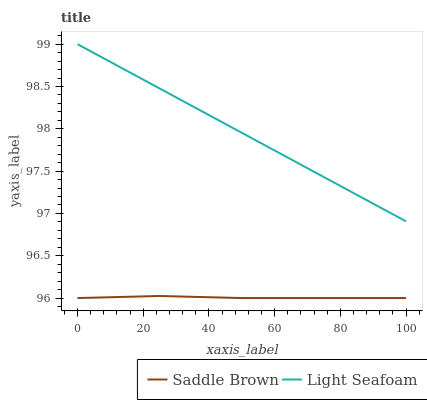Does Saddle Brown have the minimum area under the curve?
Answer yes or no. Yes. Does Light Seafoam have the maximum area under the curve?
Answer yes or no. Yes. Does Saddle Brown have the maximum area under the curve?
Answer yes or no. No. Is Light Seafoam the smoothest?
Answer yes or no. Yes. Is Saddle Brown the roughest?
Answer yes or no. Yes. Is Saddle Brown the smoothest?
Answer yes or no. No. Does Light Seafoam have the highest value?
Answer yes or no. Yes. Does Saddle Brown have the highest value?
Answer yes or no. No. Is Saddle Brown less than Light Seafoam?
Answer yes or no. Yes. Is Light Seafoam greater than Saddle Brown?
Answer yes or no. Yes. Does Saddle Brown intersect Light Seafoam?
Answer yes or no. No. 